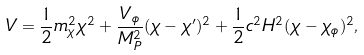<formula> <loc_0><loc_0><loc_500><loc_500>V = \frac { 1 } { 2 } m _ { \chi } ^ { 2 } \chi ^ { 2 } + \frac { V _ { \phi } } { M _ { P } ^ { 2 } } ( \chi - \chi ^ { \prime } ) ^ { 2 } + \frac { 1 } { 2 } c ^ { 2 } H ^ { 2 } ( \chi - \chi _ { \phi } ) ^ { 2 } ,</formula> 